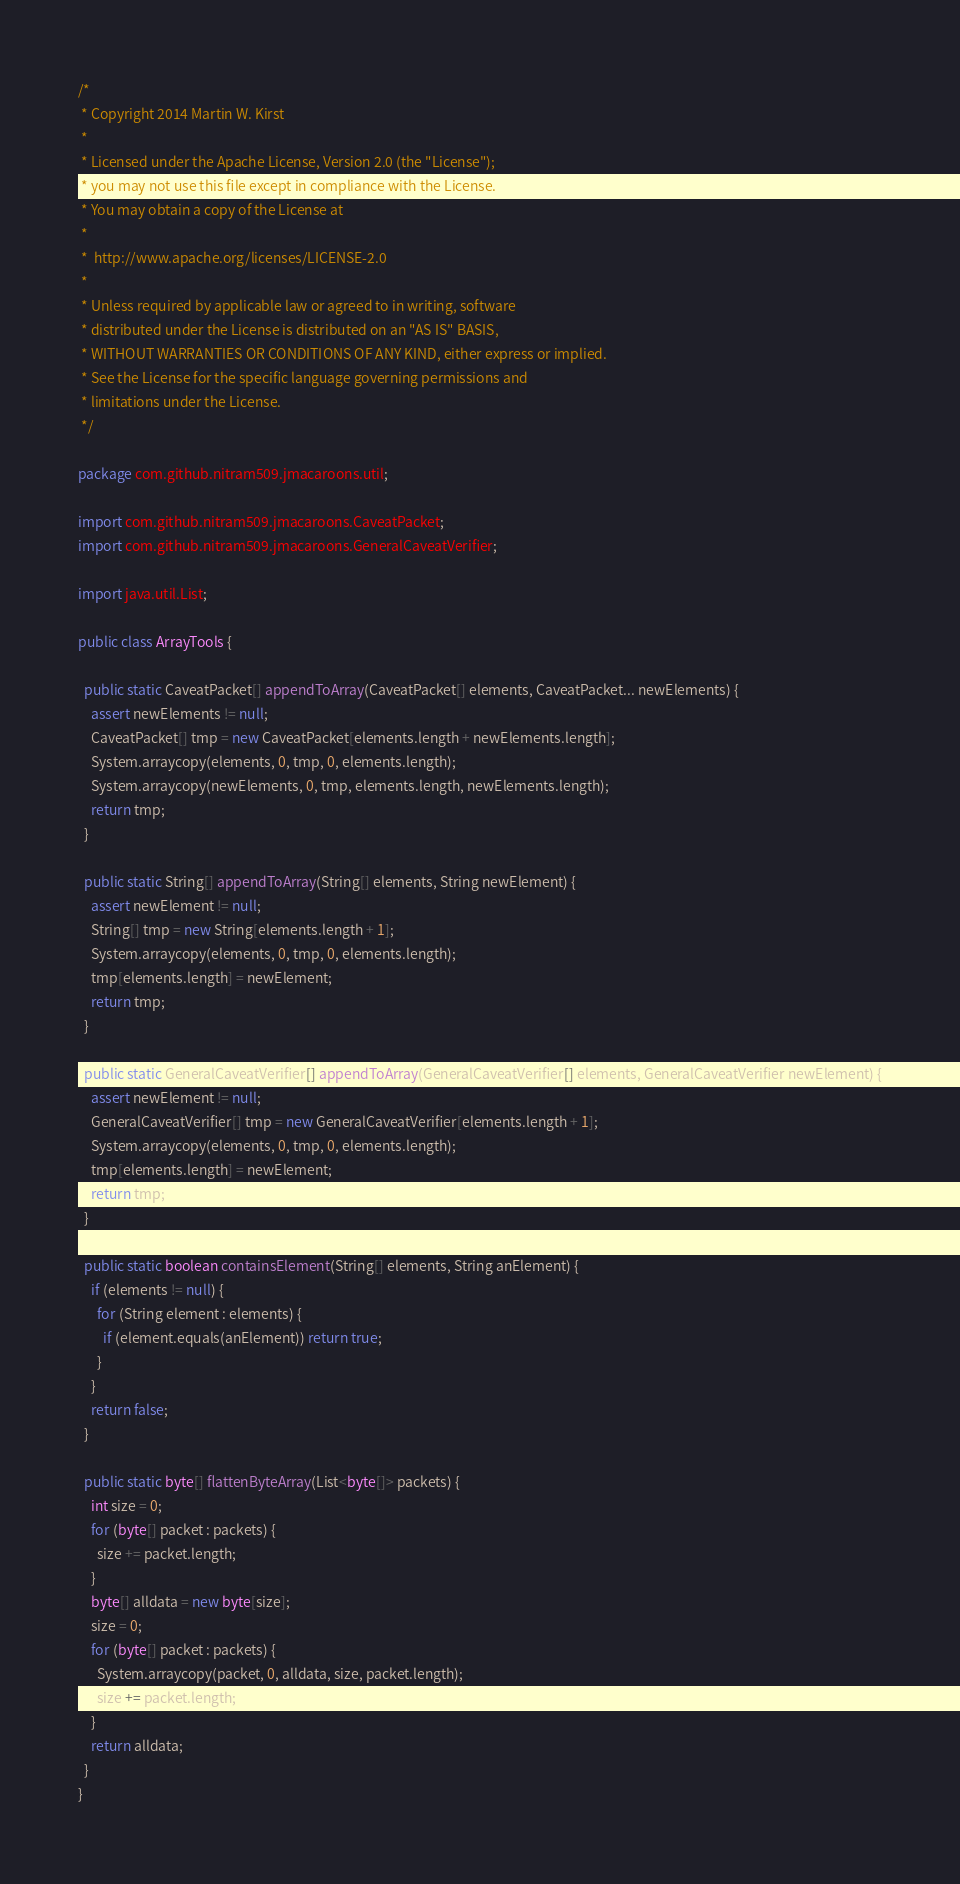Convert code to text. <code><loc_0><loc_0><loc_500><loc_500><_Java_>/*
 * Copyright 2014 Martin W. Kirst
 *
 * Licensed under the Apache License, Version 2.0 (the "License");
 * you may not use this file except in compliance with the License.
 * You may obtain a copy of the License at
 *
 *  http://www.apache.org/licenses/LICENSE-2.0
 *
 * Unless required by applicable law or agreed to in writing, software
 * distributed under the License is distributed on an "AS IS" BASIS,
 * WITHOUT WARRANTIES OR CONDITIONS OF ANY KIND, either express or implied.
 * See the License for the specific language governing permissions and
 * limitations under the License.
 */

package com.github.nitram509.jmacaroons.util;

import com.github.nitram509.jmacaroons.CaveatPacket;
import com.github.nitram509.jmacaroons.GeneralCaveatVerifier;

import java.util.List;

public class ArrayTools {

  public static CaveatPacket[] appendToArray(CaveatPacket[] elements, CaveatPacket... newElements) {
    assert newElements != null;
    CaveatPacket[] tmp = new CaveatPacket[elements.length + newElements.length];
    System.arraycopy(elements, 0, tmp, 0, elements.length);
    System.arraycopy(newElements, 0, tmp, elements.length, newElements.length);
    return tmp;
  }

  public static String[] appendToArray(String[] elements, String newElement) {
    assert newElement != null;
    String[] tmp = new String[elements.length + 1];
    System.arraycopy(elements, 0, tmp, 0, elements.length);
    tmp[elements.length] = newElement;
    return tmp;
  }

  public static GeneralCaveatVerifier[] appendToArray(GeneralCaveatVerifier[] elements, GeneralCaveatVerifier newElement) {
    assert newElement != null;
    GeneralCaveatVerifier[] tmp = new GeneralCaveatVerifier[elements.length + 1];
    System.arraycopy(elements, 0, tmp, 0, elements.length);
    tmp[elements.length] = newElement;
    return tmp;
  }

  public static boolean containsElement(String[] elements, String anElement) {
    if (elements != null) {
      for (String element : elements) {
        if (element.equals(anElement)) return true;
      }
    }
    return false;
  }

  public static byte[] flattenByteArray(List<byte[]> packets) {
    int size = 0;
    for (byte[] packet : packets) {
      size += packet.length;
    }
    byte[] alldata = new byte[size];
    size = 0;
    for (byte[] packet : packets) {
      System.arraycopy(packet, 0, alldata, size, packet.length);
      size += packet.length;
    }
    return alldata;
  }
}
</code> 